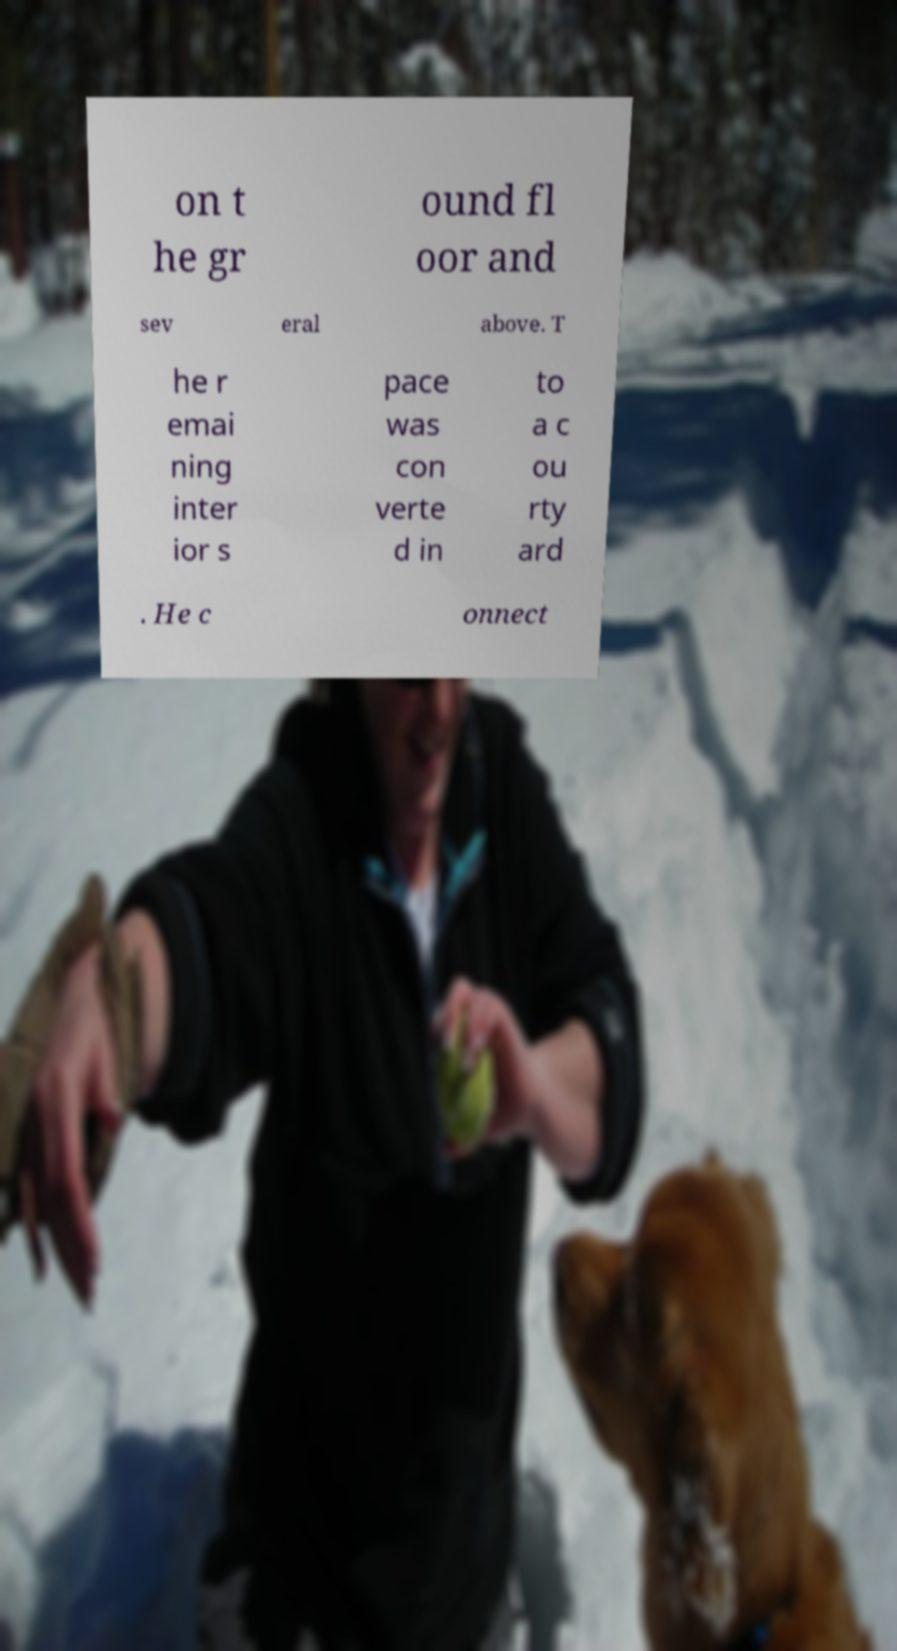Please read and relay the text visible in this image. What does it say? on t he gr ound fl oor and sev eral above. T he r emai ning inter ior s pace was con verte d in to a c ou rty ard . He c onnect 